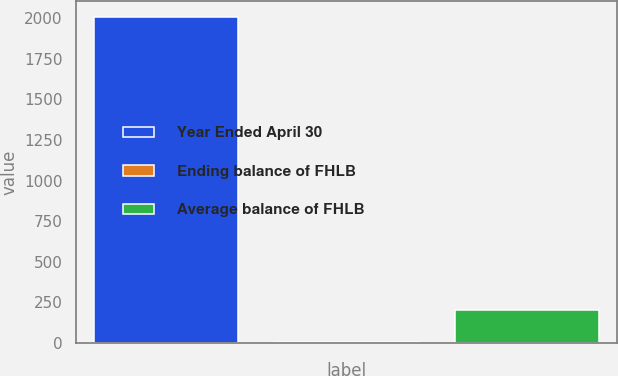Convert chart to OTSL. <chart><loc_0><loc_0><loc_500><loc_500><bar_chart><fcel>Year Ended April 30<fcel>Ending balance of FHLB<fcel>Average balance of FHLB<nl><fcel>2008<fcel>2.64<fcel>203.18<nl></chart> 